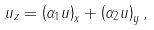<formula> <loc_0><loc_0><loc_500><loc_500>u _ { z } = \left ( \alpha _ { 1 } u \right ) _ { x } + \left ( \alpha _ { 2 } u \right ) _ { y } ,</formula> 